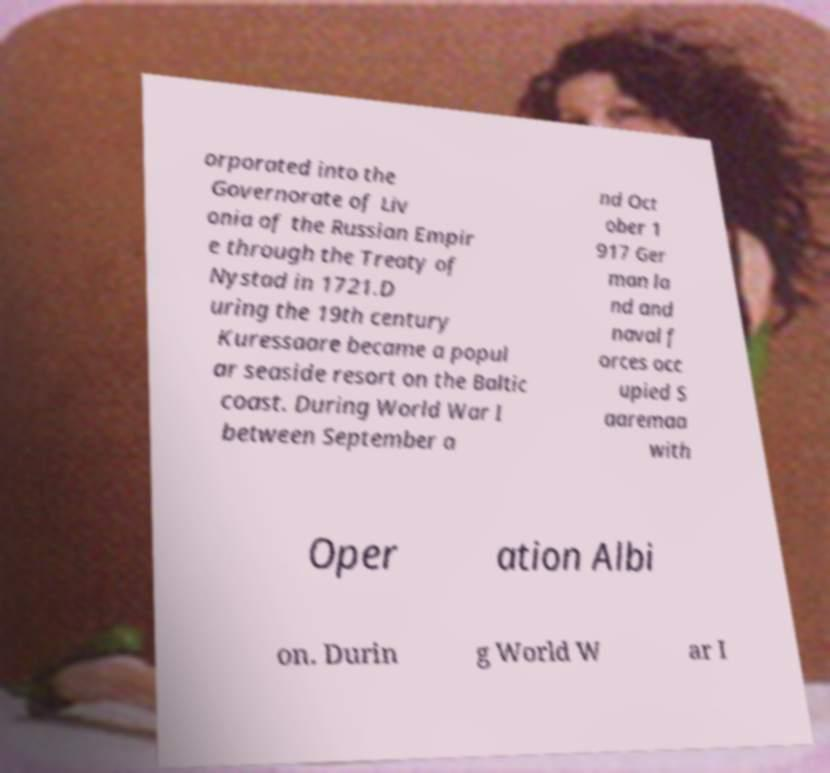There's text embedded in this image that I need extracted. Can you transcribe it verbatim? orporated into the Governorate of Liv onia of the Russian Empir e through the Treaty of Nystad in 1721.D uring the 19th century Kuressaare became a popul ar seaside resort on the Baltic coast. During World War I between September a nd Oct ober 1 917 Ger man la nd and naval f orces occ upied S aaremaa with Oper ation Albi on. Durin g World W ar I 